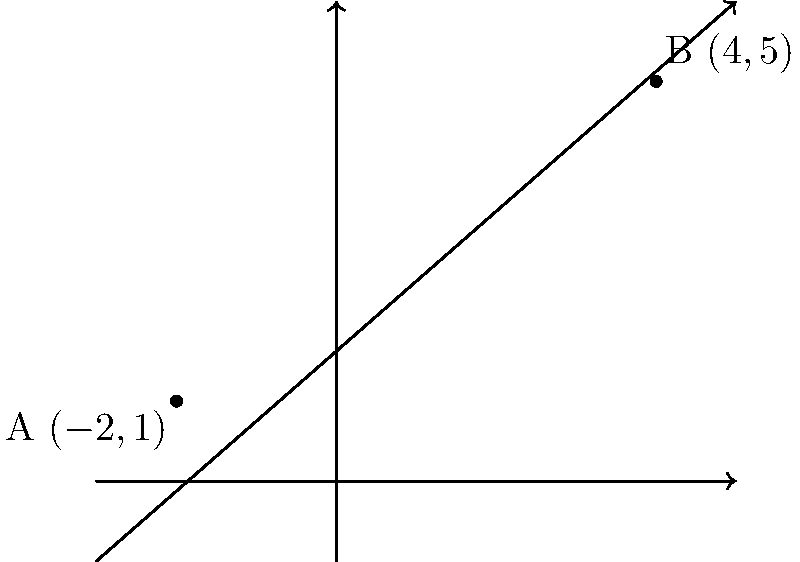In a project timeline diagram, two milestones A and B are represented by points $(-2,1)$ and $(4,5)$ respectively. Calculate the slope of the line connecting these two milestones to determine the rate of progress between them. To find the slope of the line passing through two points, we use the slope formula:

$$ m = \frac{y_2 - y_1}{x_2 - x_1} $$

Where $(x_1, y_1)$ is the first point and $(x_2, y_2)$ is the second point.

Given:
Point A: $(-2, 1)$, so $x_1 = -2$ and $y_1 = 1$
Point B: $(4, 5)$, so $x_2 = 4$ and $y_2 = 5$

Step 1: Substitute the values into the slope formula:
$$ m = \frac{5 - 1}{4 - (-2)} $$

Step 2: Simplify the numerator and denominator:
$$ m = \frac{4}{6} $$

Step 3: Reduce the fraction:
$$ m = \frac{2}{3} $$

Therefore, the slope of the line passing through points A $(-2,1)$ and B $(4,5)$ is $\frac{2}{3}$.
Answer: $\frac{2}{3}$ 